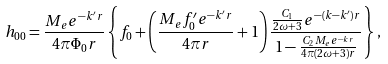<formula> <loc_0><loc_0><loc_500><loc_500>h _ { 0 0 } = \frac { M _ { e } e ^ { - k ^ { \prime } r } } { 4 \pi \Phi _ { 0 } r } \left \{ f _ { 0 } + \left ( \frac { M _ { e } f ^ { \prime } _ { 0 } e ^ { - k ^ { \prime } r } } { 4 \pi r } + 1 \right ) \frac { \frac { C _ { 1 } } { 2 \omega + 3 } e ^ { - ( k - k ^ { \prime } ) r } } { 1 - \frac { C _ { 2 } M _ { e } e ^ { - k r } } { 4 \pi ( 2 \omega + 3 ) r } } \right \} ,</formula> 